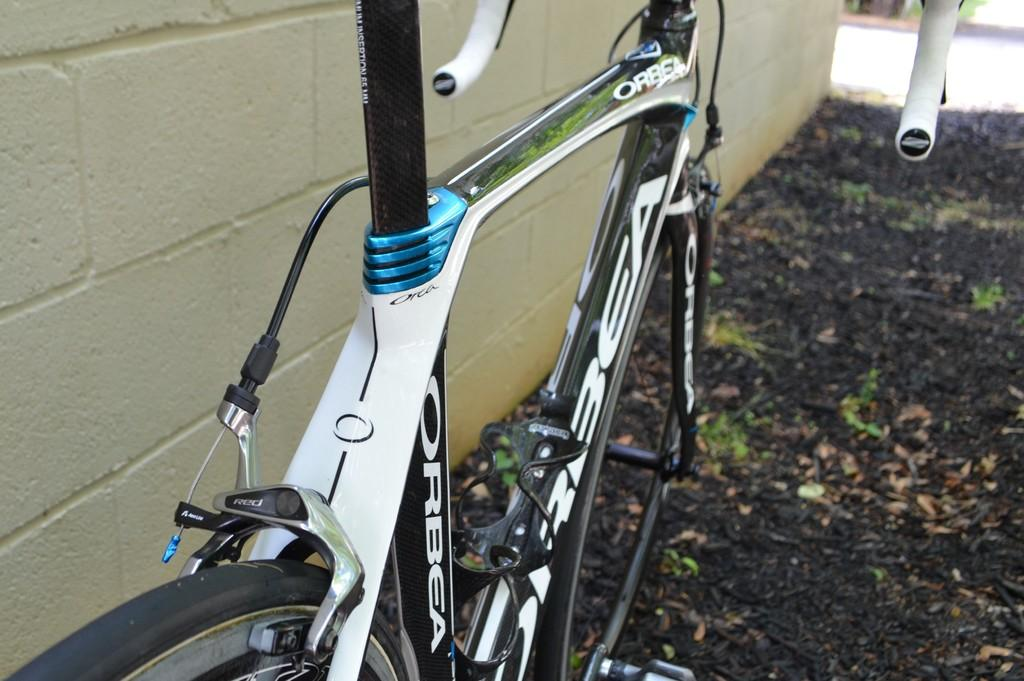What is located on the left side of the image? There is a wall on the left side of the image. What type of surface is visible on the floor? There is black soil on the floor. What mode of transportation can be seen in the image? There is a bicycle in the image. What are the main components of the bicycle? The bicycle has a frame, a handle, and paddles. What year is depicted in the image? The provided facts do not mention any specific year, so it cannot be determined from the image. What type of religious symbol can be seen on the bicycle? There is no religious symbol present on the bicycle in the image. 